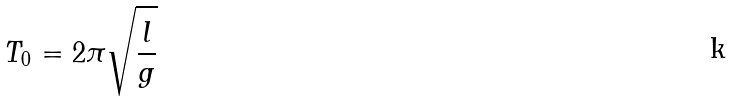<formula> <loc_0><loc_0><loc_500><loc_500>T _ { 0 } = 2 \pi \sqrt { \frac { l } { g } }</formula> 